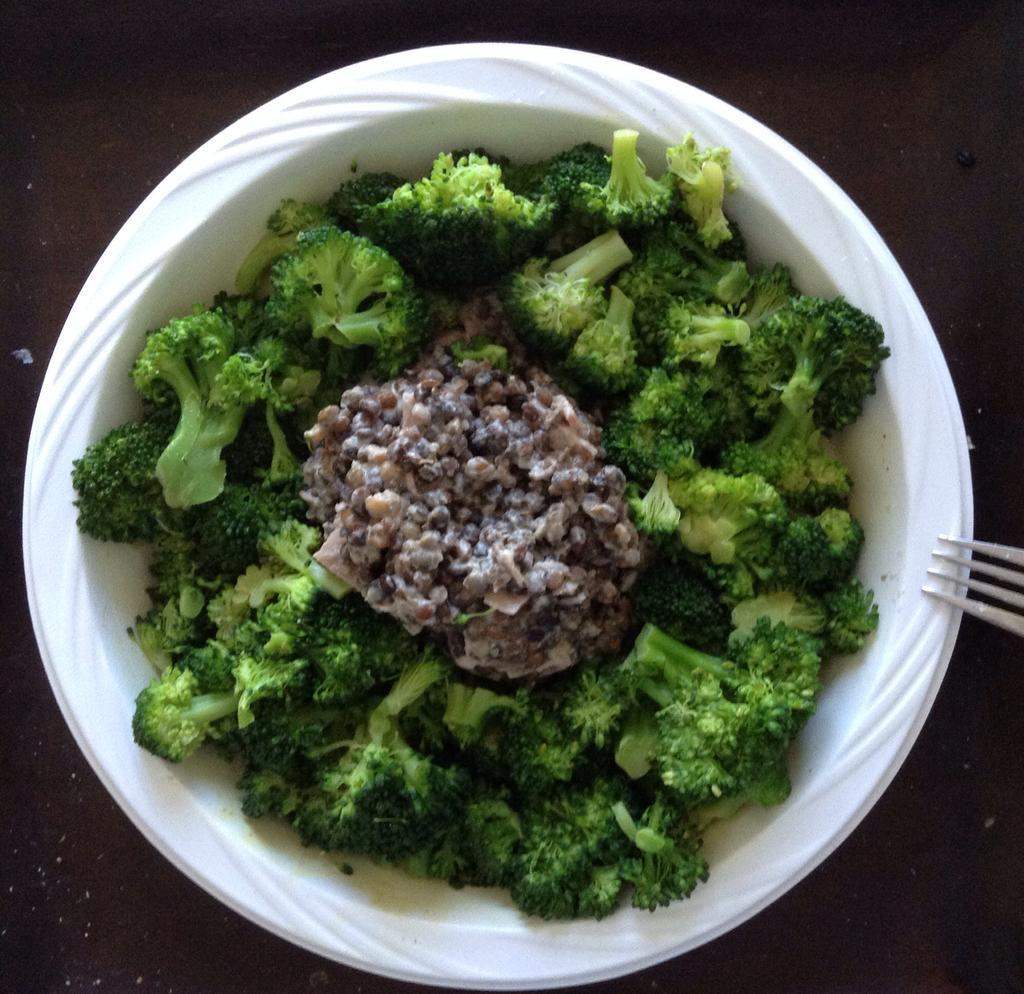Could you give a brief overview of what you see in this image? In this image, we can see broccoli and food in the white bowl. On the right side of the image, there is a fork. In the background, we can see the surface. 